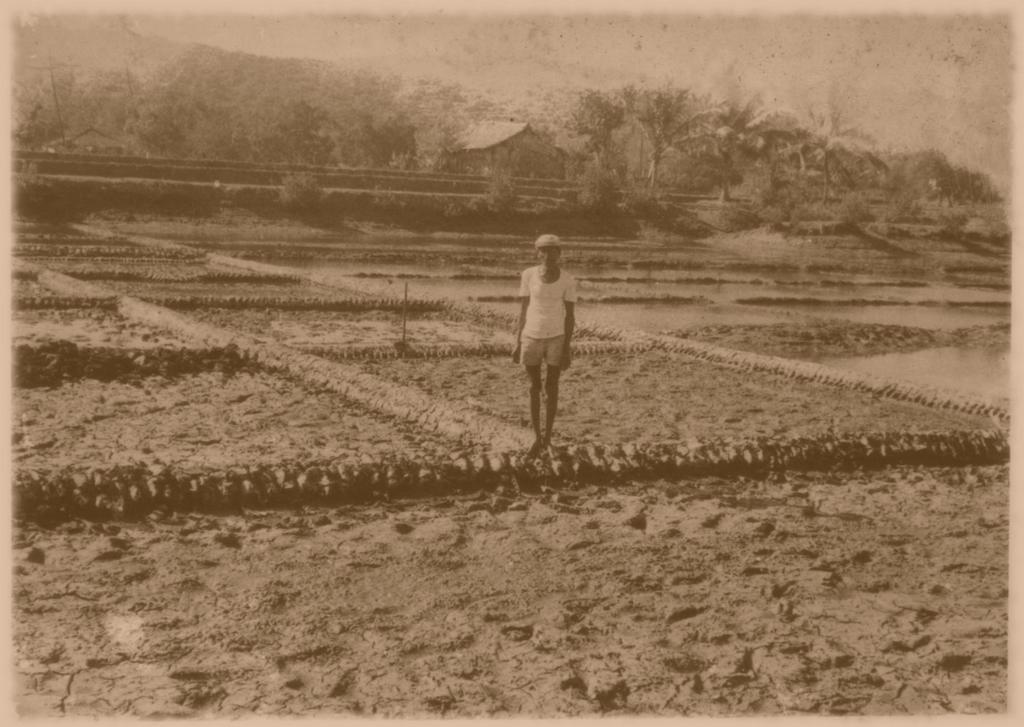Could you give a brief overview of what you see in this image? In the foreground of this image, there is a man in farming fields. In the background, we see a house, trees, mountains and the sky. 